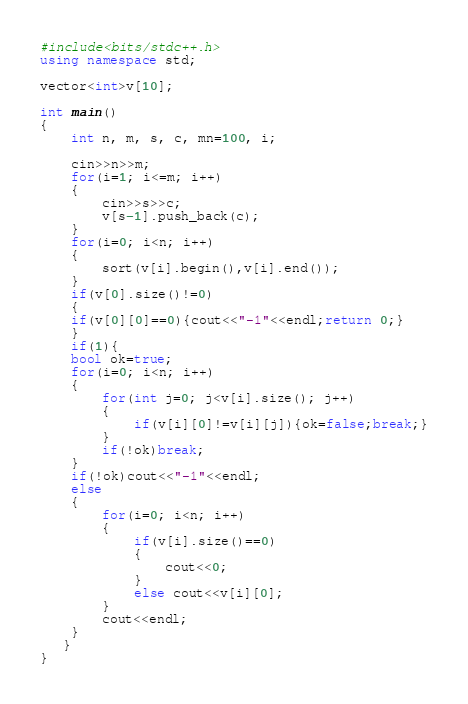<code> <loc_0><loc_0><loc_500><loc_500><_C++_>#include<bits/stdc++.h>
using namespace std;

vector<int>v[10];

int main()
{
    int n, m, s, c, mn=100, i;

    cin>>n>>m;
    for(i=1; i<=m; i++)
    {
        cin>>s>>c;
        v[s-1].push_back(c);
    }
    for(i=0; i<n; i++)
    {
        sort(v[i].begin(),v[i].end());
    }
    if(v[0].size()!=0)
    {
    if(v[0][0]==0){cout<<"-1"<<endl;return 0;}
    }
    if(1){
    bool ok=true;
    for(i=0; i<n; i++)
    {
        for(int j=0; j<v[i].size(); j++)
        {
            if(v[i][0]!=v[i][j]){ok=false;break;}
        }
        if(!ok)break;
    }
    if(!ok)cout<<"-1"<<endl;
    else
    {
        for(i=0; i<n; i++)
        {
            if(v[i].size()==0)
            {
                cout<<0;
            }
            else cout<<v[i][0];
        }
        cout<<endl;
    }
   }
}</code> 